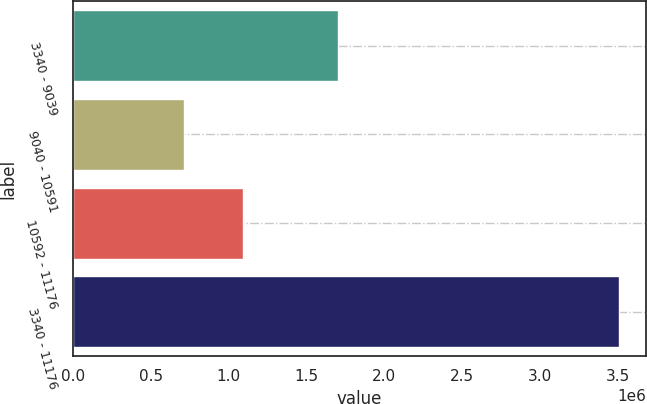<chart> <loc_0><loc_0><loc_500><loc_500><bar_chart><fcel>3340 - 9039<fcel>9040 - 10591<fcel>10592 - 11176<fcel>3340 - 11176<nl><fcel>1.7047e+06<fcel>711683<fcel>1.08992e+06<fcel>3.5063e+06<nl></chart> 